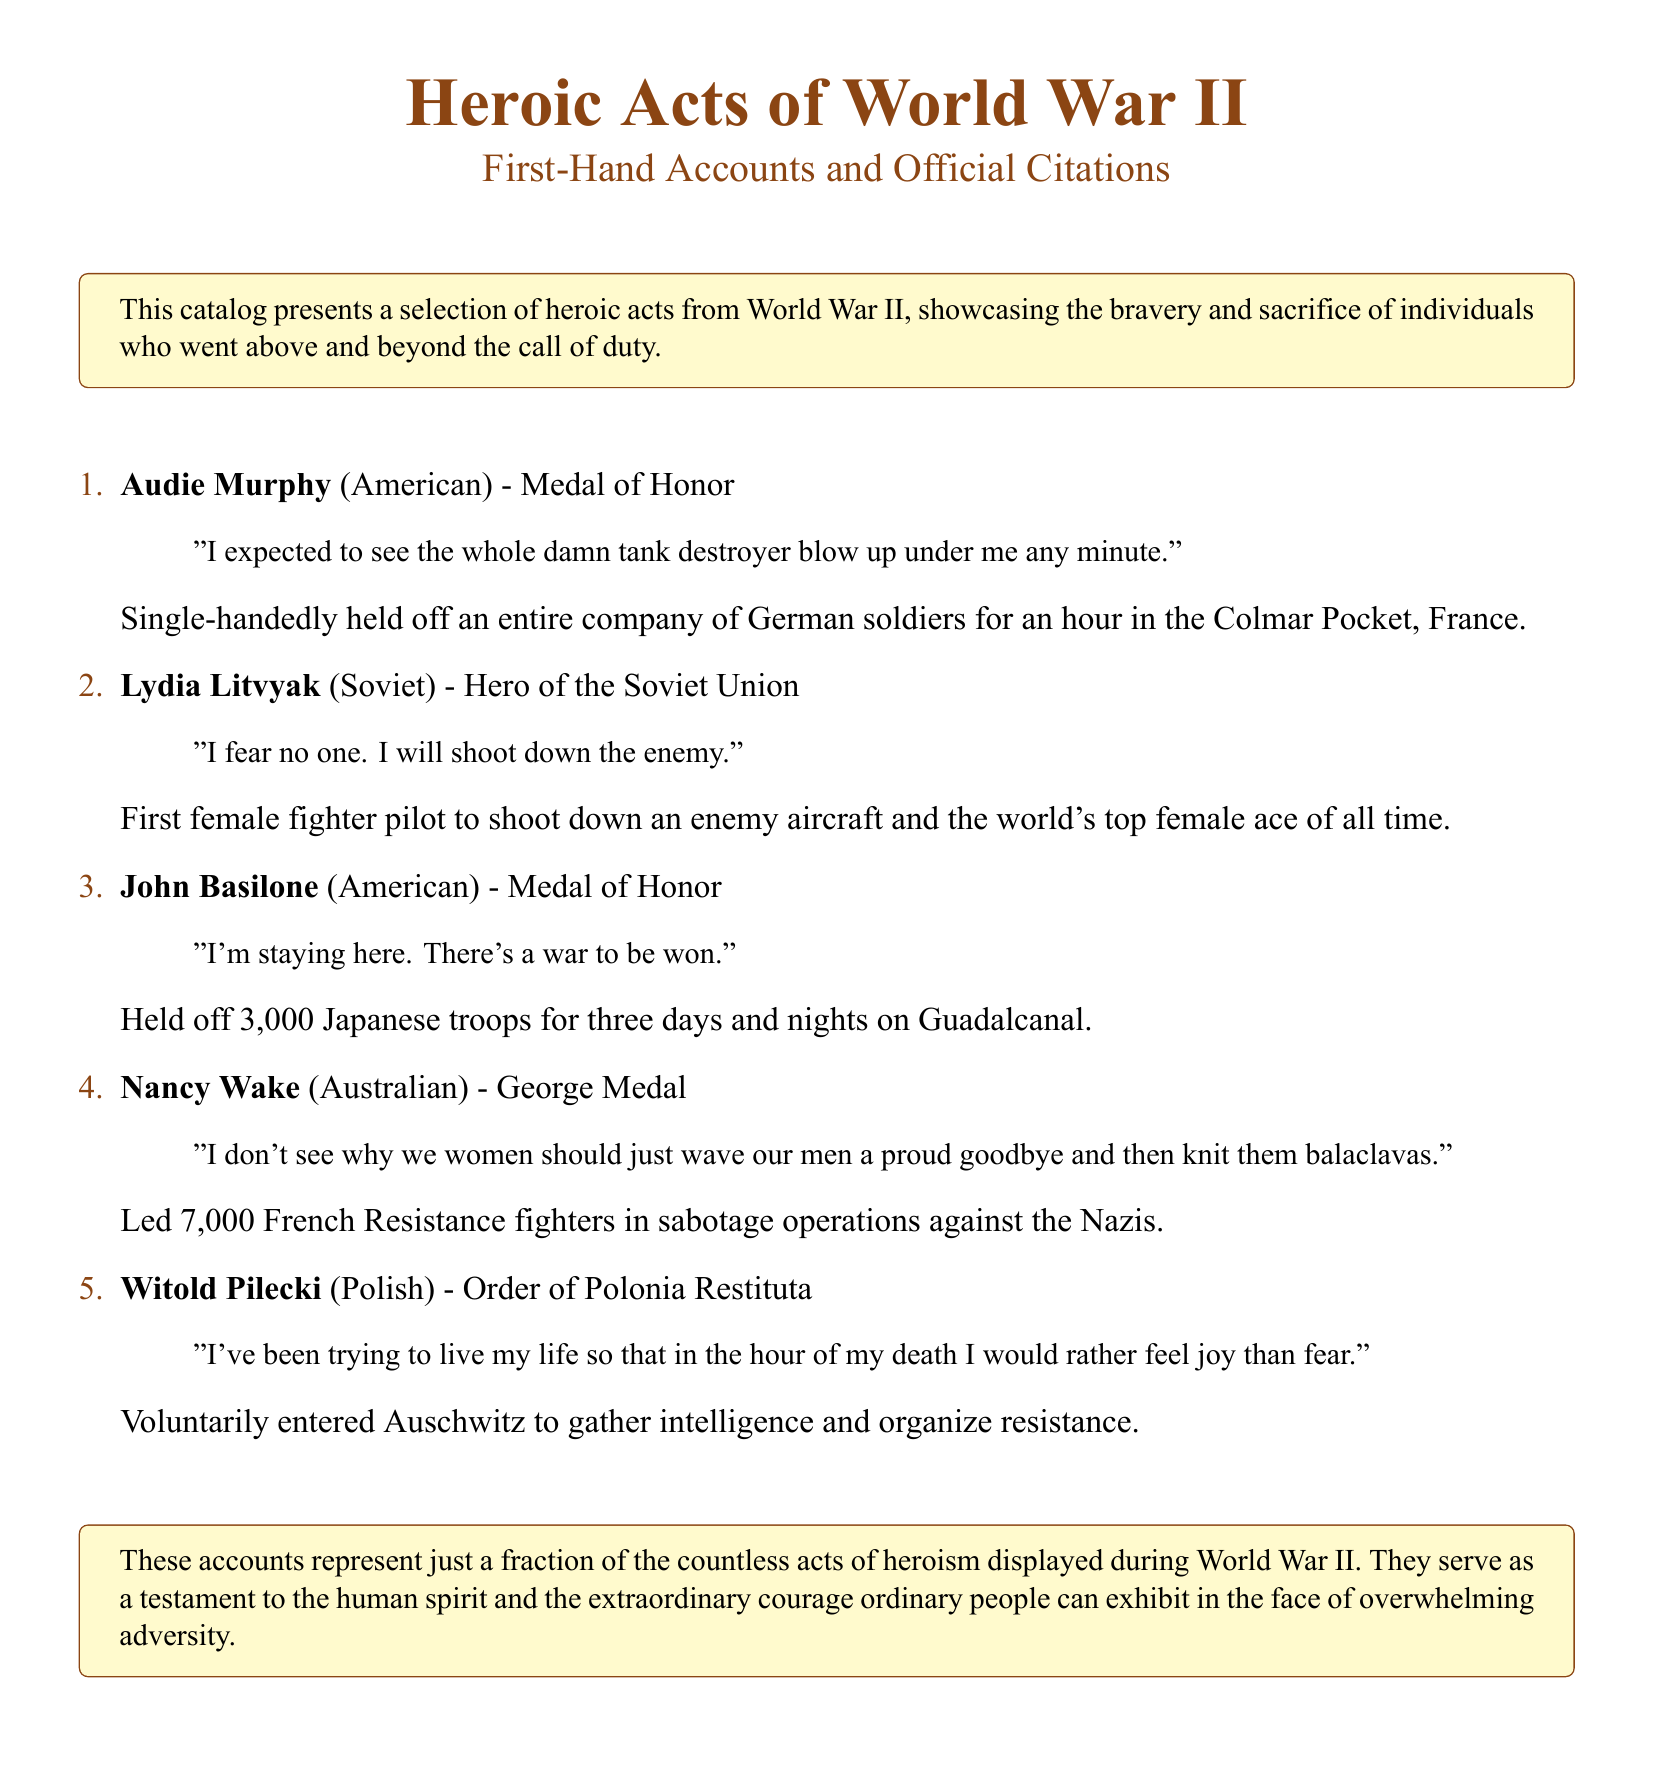What was Audie Murphy awarded? Audie Murphy was awarded the Medal of Honor for his heroic acts during World War II.
Answer: Medal of Honor Who was the first female fighter pilot to shoot down an enemy aircraft? Lydia Litvyak is recognized as the first female fighter pilot to shoot down an enemy aircraft.
Answer: Lydia Litvyak How many Japanese troops did John Basilone hold off? John Basilone held off approximately 3,000 Japanese troops during the battle on Guadalcanal.
Answer: 3,000 What medal did Nancy Wake receive? Nancy Wake received the George Medal for her leadership in sabotage operations against the Nazis.
Answer: George Medal What did Witold Pilecki do voluntarily? Witold Pilecki voluntarily entered Auschwitz to gather intelligence and organize resistance.
Answer: Entered Auschwitz Which soldier's quote indicates a determination to stay in his position? John Basilone's quote reflects his decision to remain in his position during battle.
Answer: John Basilone What is the primary theme of the document? The document primarily focuses on the heroic acts and bravery of individuals during World War II.
Answer: Heroism How many heroic acts are detailed in the catalog? The catalog presents a selection of five heroic acts from World War II.
Answer: Five What does the box at the end of the document highlight about the accounts? The box emphasizes that the accounts represent just a fraction of the countless acts of heroism in World War II.
Answer: Testament to the human spirit 